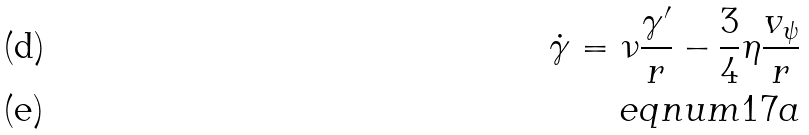Convert formula to latex. <formula><loc_0><loc_0><loc_500><loc_500>\dot { \gamma } = \nu \frac { \gamma ^ { \prime } } { r } - \frac { 3 } { 4 } \eta \frac { v _ { \psi } } { r } \\ \ e q n u m { 1 7 a }</formula> 